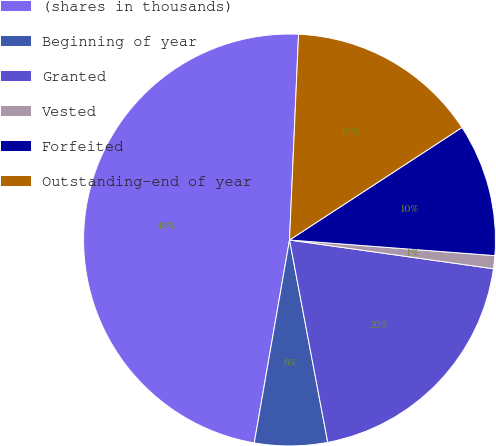Convert chart. <chart><loc_0><loc_0><loc_500><loc_500><pie_chart><fcel>(shares in thousands)<fcel>Beginning of year<fcel>Granted<fcel>Vested<fcel>Forfeited<fcel>Outstanding-end of year<nl><fcel>47.96%<fcel>5.71%<fcel>19.8%<fcel>1.02%<fcel>10.41%<fcel>15.1%<nl></chart> 